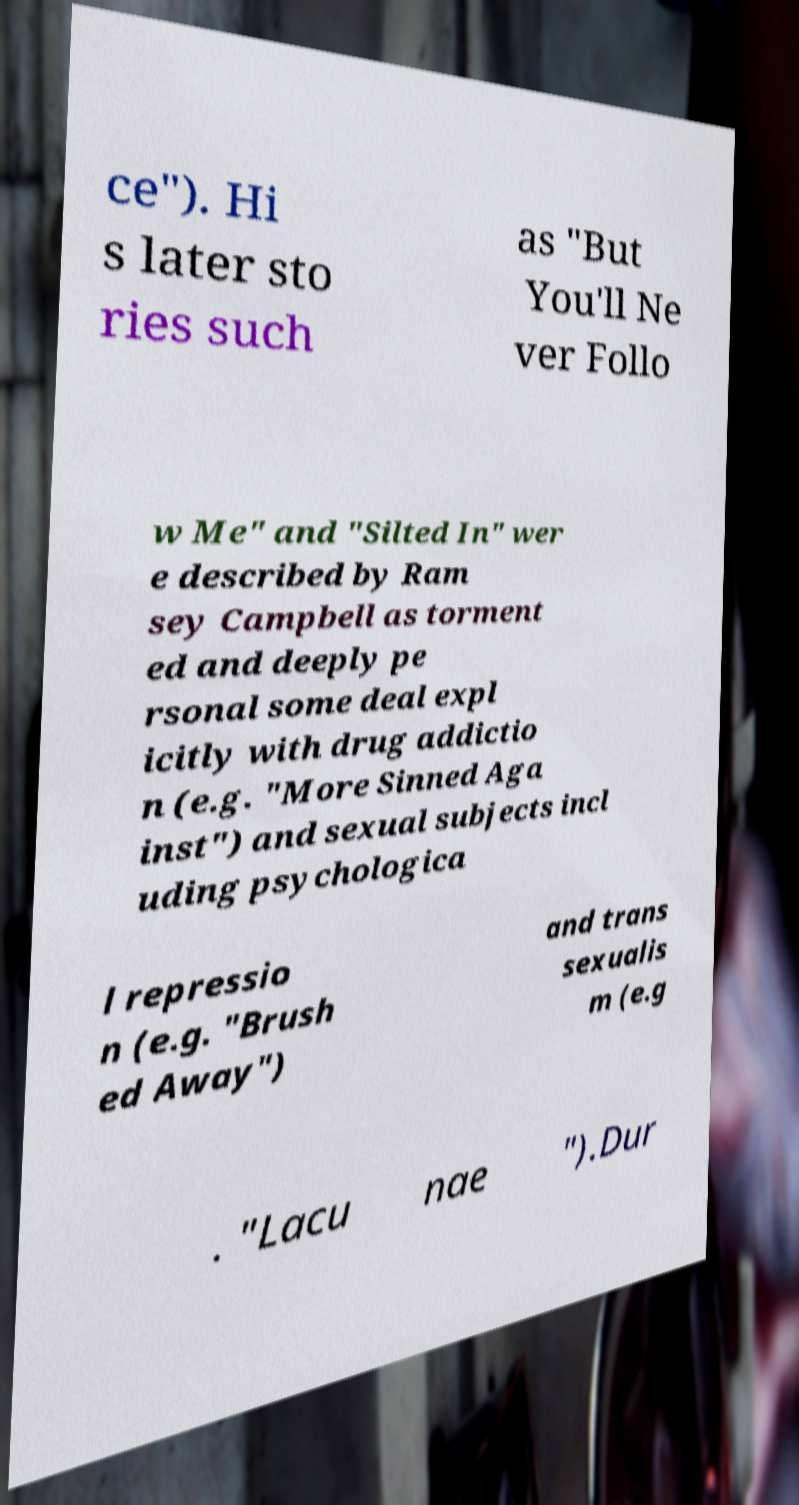What messages or text are displayed in this image? I need them in a readable, typed format. ce"). Hi s later sto ries such as "But You'll Ne ver Follo w Me" and "Silted In" wer e described by Ram sey Campbell as torment ed and deeply pe rsonal some deal expl icitly with drug addictio n (e.g. "More Sinned Aga inst") and sexual subjects incl uding psychologica l repressio n (e.g. "Brush ed Away") and trans sexualis m (e.g . "Lacu nae ").Dur 